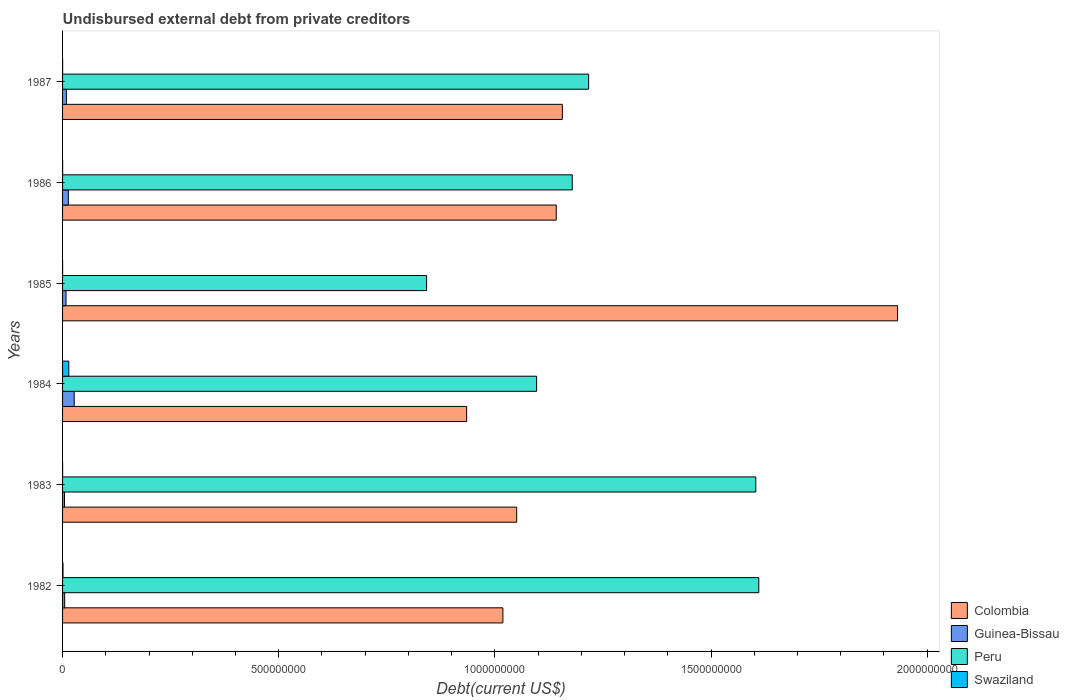How many groups of bars are there?
Provide a succinct answer. 6. Are the number of bars per tick equal to the number of legend labels?
Make the answer very short. Yes. In how many cases, is the number of bars for a given year not equal to the number of legend labels?
Ensure brevity in your answer.  0. What is the total debt in Colombia in 1983?
Ensure brevity in your answer.  1.05e+09. Across all years, what is the maximum total debt in Swaziland?
Give a very brief answer. 1.44e+07. Across all years, what is the minimum total debt in Guinea-Bissau?
Keep it short and to the point. 4.41e+06. In which year was the total debt in Peru minimum?
Provide a succinct answer. 1985. What is the total total debt in Swaziland in the graph?
Provide a short and direct response. 1.59e+07. What is the difference between the total debt in Guinea-Bissau in 1984 and that in 1985?
Your answer should be very brief. 1.90e+07. What is the difference between the total debt in Colombia in 1986 and the total debt in Peru in 1982?
Give a very brief answer. -4.69e+08. What is the average total debt in Colombia per year?
Your answer should be compact. 1.21e+09. In the year 1986, what is the difference between the total debt in Peru and total debt in Swaziland?
Offer a very short reply. 1.18e+09. In how many years, is the total debt in Peru greater than 1800000000 US$?
Your answer should be compact. 0. What is the ratio of the total debt in Swaziland in 1982 to that in 1983?
Provide a succinct answer. 10.61. Is the total debt in Swaziland in 1985 less than that in 1986?
Offer a very short reply. Yes. Is the difference between the total debt in Peru in 1982 and 1986 greater than the difference between the total debt in Swaziland in 1982 and 1986?
Your response must be concise. Yes. What is the difference between the highest and the second highest total debt in Guinea-Bissau?
Provide a short and direct response. 1.36e+07. What is the difference between the highest and the lowest total debt in Guinea-Bissau?
Provide a short and direct response. 2.25e+07. Is it the case that in every year, the sum of the total debt in Swaziland and total debt in Peru is greater than the sum of total debt in Colombia and total debt in Guinea-Bissau?
Your response must be concise. Yes. What does the 2nd bar from the top in 1983 represents?
Keep it short and to the point. Peru. What does the 2nd bar from the bottom in 1985 represents?
Offer a terse response. Guinea-Bissau. Is it the case that in every year, the sum of the total debt in Colombia and total debt in Peru is greater than the total debt in Guinea-Bissau?
Your answer should be very brief. Yes. How many bars are there?
Your answer should be very brief. 24. Are all the bars in the graph horizontal?
Keep it short and to the point. Yes. Are the values on the major ticks of X-axis written in scientific E-notation?
Provide a succinct answer. No. How are the legend labels stacked?
Your answer should be very brief. Vertical. What is the title of the graph?
Your response must be concise. Undisbursed external debt from private creditors. What is the label or title of the X-axis?
Keep it short and to the point. Debt(current US$). What is the label or title of the Y-axis?
Keep it short and to the point. Years. What is the Debt(current US$) in Colombia in 1982?
Provide a short and direct response. 1.02e+09. What is the Debt(current US$) in Guinea-Bissau in 1982?
Provide a succinct answer. 4.88e+06. What is the Debt(current US$) of Peru in 1982?
Give a very brief answer. 1.61e+09. What is the Debt(current US$) of Swaziland in 1982?
Give a very brief answer. 9.87e+05. What is the Debt(current US$) in Colombia in 1983?
Your answer should be very brief. 1.05e+09. What is the Debt(current US$) in Guinea-Bissau in 1983?
Give a very brief answer. 4.41e+06. What is the Debt(current US$) in Peru in 1983?
Provide a succinct answer. 1.60e+09. What is the Debt(current US$) of Swaziland in 1983?
Your response must be concise. 9.30e+04. What is the Debt(current US$) in Colombia in 1984?
Ensure brevity in your answer.  9.35e+08. What is the Debt(current US$) in Guinea-Bissau in 1984?
Offer a very short reply. 2.69e+07. What is the Debt(current US$) of Peru in 1984?
Keep it short and to the point. 1.10e+09. What is the Debt(current US$) of Swaziland in 1984?
Offer a terse response. 1.44e+07. What is the Debt(current US$) in Colombia in 1985?
Offer a terse response. 1.93e+09. What is the Debt(current US$) of Guinea-Bissau in 1985?
Offer a very short reply. 7.95e+06. What is the Debt(current US$) of Peru in 1985?
Your response must be concise. 8.42e+08. What is the Debt(current US$) of Swaziland in 1985?
Offer a terse response. 1.03e+05. What is the Debt(current US$) of Colombia in 1986?
Make the answer very short. 1.14e+09. What is the Debt(current US$) of Guinea-Bissau in 1986?
Your response must be concise. 1.33e+07. What is the Debt(current US$) in Peru in 1986?
Offer a terse response. 1.18e+09. What is the Debt(current US$) in Swaziland in 1986?
Your answer should be very brief. 1.21e+05. What is the Debt(current US$) in Colombia in 1987?
Provide a short and direct response. 1.16e+09. What is the Debt(current US$) in Guinea-Bissau in 1987?
Make the answer very short. 8.89e+06. What is the Debt(current US$) in Peru in 1987?
Your answer should be very brief. 1.22e+09. What is the Debt(current US$) of Swaziland in 1987?
Make the answer very short. 1.46e+05. Across all years, what is the maximum Debt(current US$) in Colombia?
Your answer should be very brief. 1.93e+09. Across all years, what is the maximum Debt(current US$) of Guinea-Bissau?
Keep it short and to the point. 2.69e+07. Across all years, what is the maximum Debt(current US$) in Peru?
Provide a succinct answer. 1.61e+09. Across all years, what is the maximum Debt(current US$) in Swaziland?
Make the answer very short. 1.44e+07. Across all years, what is the minimum Debt(current US$) of Colombia?
Offer a very short reply. 9.35e+08. Across all years, what is the minimum Debt(current US$) of Guinea-Bissau?
Offer a terse response. 4.41e+06. Across all years, what is the minimum Debt(current US$) of Peru?
Offer a terse response. 8.42e+08. Across all years, what is the minimum Debt(current US$) of Swaziland?
Offer a terse response. 9.30e+04. What is the total Debt(current US$) of Colombia in the graph?
Provide a short and direct response. 7.23e+09. What is the total Debt(current US$) in Guinea-Bissau in the graph?
Your answer should be very brief. 6.64e+07. What is the total Debt(current US$) in Peru in the graph?
Provide a short and direct response. 7.55e+09. What is the total Debt(current US$) of Swaziland in the graph?
Your answer should be very brief. 1.59e+07. What is the difference between the Debt(current US$) of Colombia in 1982 and that in 1983?
Offer a terse response. -3.20e+07. What is the difference between the Debt(current US$) of Guinea-Bissau in 1982 and that in 1983?
Provide a short and direct response. 4.74e+05. What is the difference between the Debt(current US$) of Peru in 1982 and that in 1983?
Provide a succinct answer. 6.94e+06. What is the difference between the Debt(current US$) in Swaziland in 1982 and that in 1983?
Offer a terse response. 8.94e+05. What is the difference between the Debt(current US$) of Colombia in 1982 and that in 1984?
Offer a very short reply. 8.38e+07. What is the difference between the Debt(current US$) of Guinea-Bissau in 1982 and that in 1984?
Keep it short and to the point. -2.20e+07. What is the difference between the Debt(current US$) in Peru in 1982 and that in 1984?
Your answer should be compact. 5.14e+08. What is the difference between the Debt(current US$) in Swaziland in 1982 and that in 1984?
Provide a short and direct response. -1.34e+07. What is the difference between the Debt(current US$) in Colombia in 1982 and that in 1985?
Your answer should be compact. -9.13e+08. What is the difference between the Debt(current US$) of Guinea-Bissau in 1982 and that in 1985?
Give a very brief answer. -3.07e+06. What is the difference between the Debt(current US$) in Peru in 1982 and that in 1985?
Make the answer very short. 7.68e+08. What is the difference between the Debt(current US$) of Swaziland in 1982 and that in 1985?
Offer a terse response. 8.84e+05. What is the difference between the Debt(current US$) of Colombia in 1982 and that in 1986?
Offer a terse response. -1.23e+08. What is the difference between the Debt(current US$) in Guinea-Bissau in 1982 and that in 1986?
Offer a terse response. -8.41e+06. What is the difference between the Debt(current US$) of Peru in 1982 and that in 1986?
Give a very brief answer. 4.31e+08. What is the difference between the Debt(current US$) of Swaziland in 1982 and that in 1986?
Your answer should be compact. 8.66e+05. What is the difference between the Debt(current US$) in Colombia in 1982 and that in 1987?
Give a very brief answer. -1.38e+08. What is the difference between the Debt(current US$) of Guinea-Bissau in 1982 and that in 1987?
Offer a terse response. -4.00e+06. What is the difference between the Debt(current US$) in Peru in 1982 and that in 1987?
Your response must be concise. 3.94e+08. What is the difference between the Debt(current US$) in Swaziland in 1982 and that in 1987?
Your answer should be compact. 8.41e+05. What is the difference between the Debt(current US$) in Colombia in 1983 and that in 1984?
Give a very brief answer. 1.16e+08. What is the difference between the Debt(current US$) of Guinea-Bissau in 1983 and that in 1984?
Your response must be concise. -2.25e+07. What is the difference between the Debt(current US$) of Peru in 1983 and that in 1984?
Your answer should be very brief. 5.07e+08. What is the difference between the Debt(current US$) of Swaziland in 1983 and that in 1984?
Offer a terse response. -1.43e+07. What is the difference between the Debt(current US$) of Colombia in 1983 and that in 1985?
Offer a terse response. -8.81e+08. What is the difference between the Debt(current US$) of Guinea-Bissau in 1983 and that in 1985?
Make the answer very short. -3.54e+06. What is the difference between the Debt(current US$) in Peru in 1983 and that in 1985?
Make the answer very short. 7.61e+08. What is the difference between the Debt(current US$) of Colombia in 1983 and that in 1986?
Your response must be concise. -9.15e+07. What is the difference between the Debt(current US$) in Guinea-Bissau in 1983 and that in 1986?
Provide a succinct answer. -8.89e+06. What is the difference between the Debt(current US$) of Peru in 1983 and that in 1986?
Offer a very short reply. 4.25e+08. What is the difference between the Debt(current US$) of Swaziland in 1983 and that in 1986?
Offer a terse response. -2.80e+04. What is the difference between the Debt(current US$) in Colombia in 1983 and that in 1987?
Offer a very short reply. -1.06e+08. What is the difference between the Debt(current US$) in Guinea-Bissau in 1983 and that in 1987?
Give a very brief answer. -4.48e+06. What is the difference between the Debt(current US$) in Peru in 1983 and that in 1987?
Ensure brevity in your answer.  3.87e+08. What is the difference between the Debt(current US$) in Swaziland in 1983 and that in 1987?
Ensure brevity in your answer.  -5.30e+04. What is the difference between the Debt(current US$) of Colombia in 1984 and that in 1985?
Your answer should be compact. -9.97e+08. What is the difference between the Debt(current US$) of Guinea-Bissau in 1984 and that in 1985?
Your answer should be very brief. 1.90e+07. What is the difference between the Debt(current US$) of Peru in 1984 and that in 1985?
Your answer should be very brief. 2.54e+08. What is the difference between the Debt(current US$) in Swaziland in 1984 and that in 1985?
Provide a succinct answer. 1.43e+07. What is the difference between the Debt(current US$) of Colombia in 1984 and that in 1986?
Ensure brevity in your answer.  -2.07e+08. What is the difference between the Debt(current US$) of Guinea-Bissau in 1984 and that in 1986?
Offer a terse response. 1.36e+07. What is the difference between the Debt(current US$) of Peru in 1984 and that in 1986?
Make the answer very short. -8.25e+07. What is the difference between the Debt(current US$) of Swaziland in 1984 and that in 1986?
Offer a terse response. 1.43e+07. What is the difference between the Debt(current US$) in Colombia in 1984 and that in 1987?
Offer a very short reply. -2.21e+08. What is the difference between the Debt(current US$) of Guinea-Bissau in 1984 and that in 1987?
Ensure brevity in your answer.  1.80e+07. What is the difference between the Debt(current US$) in Peru in 1984 and that in 1987?
Your answer should be very brief. -1.20e+08. What is the difference between the Debt(current US$) in Swaziland in 1984 and that in 1987?
Ensure brevity in your answer.  1.43e+07. What is the difference between the Debt(current US$) of Colombia in 1985 and that in 1986?
Offer a very short reply. 7.90e+08. What is the difference between the Debt(current US$) of Guinea-Bissau in 1985 and that in 1986?
Your answer should be compact. -5.34e+06. What is the difference between the Debt(current US$) in Peru in 1985 and that in 1986?
Offer a terse response. -3.37e+08. What is the difference between the Debt(current US$) in Swaziland in 1985 and that in 1986?
Ensure brevity in your answer.  -1.80e+04. What is the difference between the Debt(current US$) in Colombia in 1985 and that in 1987?
Ensure brevity in your answer.  7.75e+08. What is the difference between the Debt(current US$) in Guinea-Bissau in 1985 and that in 1987?
Give a very brief answer. -9.33e+05. What is the difference between the Debt(current US$) in Peru in 1985 and that in 1987?
Ensure brevity in your answer.  -3.75e+08. What is the difference between the Debt(current US$) in Swaziland in 1985 and that in 1987?
Give a very brief answer. -4.30e+04. What is the difference between the Debt(current US$) in Colombia in 1986 and that in 1987?
Your response must be concise. -1.41e+07. What is the difference between the Debt(current US$) in Guinea-Bissau in 1986 and that in 1987?
Provide a succinct answer. 4.41e+06. What is the difference between the Debt(current US$) of Peru in 1986 and that in 1987?
Make the answer very short. -3.78e+07. What is the difference between the Debt(current US$) in Swaziland in 1986 and that in 1987?
Provide a short and direct response. -2.50e+04. What is the difference between the Debt(current US$) in Colombia in 1982 and the Debt(current US$) in Guinea-Bissau in 1983?
Your answer should be compact. 1.01e+09. What is the difference between the Debt(current US$) in Colombia in 1982 and the Debt(current US$) in Peru in 1983?
Offer a very short reply. -5.85e+08. What is the difference between the Debt(current US$) in Colombia in 1982 and the Debt(current US$) in Swaziland in 1983?
Give a very brief answer. 1.02e+09. What is the difference between the Debt(current US$) in Guinea-Bissau in 1982 and the Debt(current US$) in Peru in 1983?
Ensure brevity in your answer.  -1.60e+09. What is the difference between the Debt(current US$) in Guinea-Bissau in 1982 and the Debt(current US$) in Swaziland in 1983?
Provide a short and direct response. 4.79e+06. What is the difference between the Debt(current US$) in Peru in 1982 and the Debt(current US$) in Swaziland in 1983?
Provide a succinct answer. 1.61e+09. What is the difference between the Debt(current US$) in Colombia in 1982 and the Debt(current US$) in Guinea-Bissau in 1984?
Your response must be concise. 9.92e+08. What is the difference between the Debt(current US$) in Colombia in 1982 and the Debt(current US$) in Peru in 1984?
Your response must be concise. -7.80e+07. What is the difference between the Debt(current US$) in Colombia in 1982 and the Debt(current US$) in Swaziland in 1984?
Ensure brevity in your answer.  1.00e+09. What is the difference between the Debt(current US$) of Guinea-Bissau in 1982 and the Debt(current US$) of Peru in 1984?
Keep it short and to the point. -1.09e+09. What is the difference between the Debt(current US$) in Guinea-Bissau in 1982 and the Debt(current US$) in Swaziland in 1984?
Give a very brief answer. -9.52e+06. What is the difference between the Debt(current US$) of Peru in 1982 and the Debt(current US$) of Swaziland in 1984?
Your answer should be very brief. 1.60e+09. What is the difference between the Debt(current US$) of Colombia in 1982 and the Debt(current US$) of Guinea-Bissau in 1985?
Keep it short and to the point. 1.01e+09. What is the difference between the Debt(current US$) of Colombia in 1982 and the Debt(current US$) of Peru in 1985?
Your response must be concise. 1.76e+08. What is the difference between the Debt(current US$) in Colombia in 1982 and the Debt(current US$) in Swaziland in 1985?
Offer a terse response. 1.02e+09. What is the difference between the Debt(current US$) of Guinea-Bissau in 1982 and the Debt(current US$) of Peru in 1985?
Provide a succinct answer. -8.37e+08. What is the difference between the Debt(current US$) of Guinea-Bissau in 1982 and the Debt(current US$) of Swaziland in 1985?
Make the answer very short. 4.78e+06. What is the difference between the Debt(current US$) in Peru in 1982 and the Debt(current US$) in Swaziland in 1985?
Give a very brief answer. 1.61e+09. What is the difference between the Debt(current US$) in Colombia in 1982 and the Debt(current US$) in Guinea-Bissau in 1986?
Keep it short and to the point. 1.01e+09. What is the difference between the Debt(current US$) of Colombia in 1982 and the Debt(current US$) of Peru in 1986?
Offer a terse response. -1.60e+08. What is the difference between the Debt(current US$) in Colombia in 1982 and the Debt(current US$) in Swaziland in 1986?
Provide a succinct answer. 1.02e+09. What is the difference between the Debt(current US$) of Guinea-Bissau in 1982 and the Debt(current US$) of Peru in 1986?
Your answer should be very brief. -1.17e+09. What is the difference between the Debt(current US$) of Guinea-Bissau in 1982 and the Debt(current US$) of Swaziland in 1986?
Your answer should be very brief. 4.76e+06. What is the difference between the Debt(current US$) in Peru in 1982 and the Debt(current US$) in Swaziland in 1986?
Your answer should be very brief. 1.61e+09. What is the difference between the Debt(current US$) of Colombia in 1982 and the Debt(current US$) of Guinea-Bissau in 1987?
Your answer should be very brief. 1.01e+09. What is the difference between the Debt(current US$) of Colombia in 1982 and the Debt(current US$) of Peru in 1987?
Ensure brevity in your answer.  -1.98e+08. What is the difference between the Debt(current US$) of Colombia in 1982 and the Debt(current US$) of Swaziland in 1987?
Ensure brevity in your answer.  1.02e+09. What is the difference between the Debt(current US$) in Guinea-Bissau in 1982 and the Debt(current US$) in Peru in 1987?
Ensure brevity in your answer.  -1.21e+09. What is the difference between the Debt(current US$) of Guinea-Bissau in 1982 and the Debt(current US$) of Swaziland in 1987?
Your answer should be compact. 4.74e+06. What is the difference between the Debt(current US$) in Peru in 1982 and the Debt(current US$) in Swaziland in 1987?
Give a very brief answer. 1.61e+09. What is the difference between the Debt(current US$) of Colombia in 1983 and the Debt(current US$) of Guinea-Bissau in 1984?
Your answer should be very brief. 1.02e+09. What is the difference between the Debt(current US$) in Colombia in 1983 and the Debt(current US$) in Peru in 1984?
Offer a terse response. -4.60e+07. What is the difference between the Debt(current US$) in Colombia in 1983 and the Debt(current US$) in Swaziland in 1984?
Ensure brevity in your answer.  1.04e+09. What is the difference between the Debt(current US$) of Guinea-Bissau in 1983 and the Debt(current US$) of Peru in 1984?
Provide a short and direct response. -1.09e+09. What is the difference between the Debt(current US$) of Guinea-Bissau in 1983 and the Debt(current US$) of Swaziland in 1984?
Keep it short and to the point. -9.99e+06. What is the difference between the Debt(current US$) in Peru in 1983 and the Debt(current US$) in Swaziland in 1984?
Offer a terse response. 1.59e+09. What is the difference between the Debt(current US$) of Colombia in 1983 and the Debt(current US$) of Guinea-Bissau in 1985?
Your answer should be compact. 1.04e+09. What is the difference between the Debt(current US$) in Colombia in 1983 and the Debt(current US$) in Peru in 1985?
Your answer should be very brief. 2.08e+08. What is the difference between the Debt(current US$) in Colombia in 1983 and the Debt(current US$) in Swaziland in 1985?
Provide a succinct answer. 1.05e+09. What is the difference between the Debt(current US$) in Guinea-Bissau in 1983 and the Debt(current US$) in Peru in 1985?
Give a very brief answer. -8.38e+08. What is the difference between the Debt(current US$) in Guinea-Bissau in 1983 and the Debt(current US$) in Swaziland in 1985?
Provide a short and direct response. 4.31e+06. What is the difference between the Debt(current US$) in Peru in 1983 and the Debt(current US$) in Swaziland in 1985?
Provide a succinct answer. 1.60e+09. What is the difference between the Debt(current US$) of Colombia in 1983 and the Debt(current US$) of Guinea-Bissau in 1986?
Provide a succinct answer. 1.04e+09. What is the difference between the Debt(current US$) in Colombia in 1983 and the Debt(current US$) in Peru in 1986?
Offer a very short reply. -1.29e+08. What is the difference between the Debt(current US$) of Colombia in 1983 and the Debt(current US$) of Swaziland in 1986?
Your response must be concise. 1.05e+09. What is the difference between the Debt(current US$) of Guinea-Bissau in 1983 and the Debt(current US$) of Peru in 1986?
Offer a terse response. -1.17e+09. What is the difference between the Debt(current US$) in Guinea-Bissau in 1983 and the Debt(current US$) in Swaziland in 1986?
Your answer should be compact. 4.29e+06. What is the difference between the Debt(current US$) of Peru in 1983 and the Debt(current US$) of Swaziland in 1986?
Your answer should be very brief. 1.60e+09. What is the difference between the Debt(current US$) of Colombia in 1983 and the Debt(current US$) of Guinea-Bissau in 1987?
Provide a short and direct response. 1.04e+09. What is the difference between the Debt(current US$) of Colombia in 1983 and the Debt(current US$) of Peru in 1987?
Give a very brief answer. -1.66e+08. What is the difference between the Debt(current US$) of Colombia in 1983 and the Debt(current US$) of Swaziland in 1987?
Make the answer very short. 1.05e+09. What is the difference between the Debt(current US$) of Guinea-Bissau in 1983 and the Debt(current US$) of Peru in 1987?
Make the answer very short. -1.21e+09. What is the difference between the Debt(current US$) in Guinea-Bissau in 1983 and the Debt(current US$) in Swaziland in 1987?
Provide a short and direct response. 4.26e+06. What is the difference between the Debt(current US$) in Peru in 1983 and the Debt(current US$) in Swaziland in 1987?
Provide a short and direct response. 1.60e+09. What is the difference between the Debt(current US$) of Colombia in 1984 and the Debt(current US$) of Guinea-Bissau in 1985?
Your answer should be very brief. 9.27e+08. What is the difference between the Debt(current US$) in Colombia in 1984 and the Debt(current US$) in Peru in 1985?
Give a very brief answer. 9.26e+07. What is the difference between the Debt(current US$) of Colombia in 1984 and the Debt(current US$) of Swaziland in 1985?
Your response must be concise. 9.35e+08. What is the difference between the Debt(current US$) of Guinea-Bissau in 1984 and the Debt(current US$) of Peru in 1985?
Provide a short and direct response. -8.15e+08. What is the difference between the Debt(current US$) in Guinea-Bissau in 1984 and the Debt(current US$) in Swaziland in 1985?
Make the answer very short. 2.68e+07. What is the difference between the Debt(current US$) in Peru in 1984 and the Debt(current US$) in Swaziland in 1985?
Ensure brevity in your answer.  1.10e+09. What is the difference between the Debt(current US$) of Colombia in 1984 and the Debt(current US$) of Guinea-Bissau in 1986?
Keep it short and to the point. 9.21e+08. What is the difference between the Debt(current US$) in Colombia in 1984 and the Debt(current US$) in Peru in 1986?
Keep it short and to the point. -2.44e+08. What is the difference between the Debt(current US$) in Colombia in 1984 and the Debt(current US$) in Swaziland in 1986?
Your answer should be very brief. 9.35e+08. What is the difference between the Debt(current US$) of Guinea-Bissau in 1984 and the Debt(current US$) of Peru in 1986?
Make the answer very short. -1.15e+09. What is the difference between the Debt(current US$) of Guinea-Bissau in 1984 and the Debt(current US$) of Swaziland in 1986?
Give a very brief answer. 2.68e+07. What is the difference between the Debt(current US$) of Peru in 1984 and the Debt(current US$) of Swaziland in 1986?
Offer a very short reply. 1.10e+09. What is the difference between the Debt(current US$) in Colombia in 1984 and the Debt(current US$) in Guinea-Bissau in 1987?
Ensure brevity in your answer.  9.26e+08. What is the difference between the Debt(current US$) of Colombia in 1984 and the Debt(current US$) of Peru in 1987?
Provide a short and direct response. -2.82e+08. What is the difference between the Debt(current US$) in Colombia in 1984 and the Debt(current US$) in Swaziland in 1987?
Offer a very short reply. 9.35e+08. What is the difference between the Debt(current US$) of Guinea-Bissau in 1984 and the Debt(current US$) of Peru in 1987?
Make the answer very short. -1.19e+09. What is the difference between the Debt(current US$) of Guinea-Bissau in 1984 and the Debt(current US$) of Swaziland in 1987?
Give a very brief answer. 2.68e+07. What is the difference between the Debt(current US$) in Peru in 1984 and the Debt(current US$) in Swaziland in 1987?
Give a very brief answer. 1.10e+09. What is the difference between the Debt(current US$) of Colombia in 1985 and the Debt(current US$) of Guinea-Bissau in 1986?
Provide a short and direct response. 1.92e+09. What is the difference between the Debt(current US$) in Colombia in 1985 and the Debt(current US$) in Peru in 1986?
Offer a terse response. 7.52e+08. What is the difference between the Debt(current US$) in Colombia in 1985 and the Debt(current US$) in Swaziland in 1986?
Make the answer very short. 1.93e+09. What is the difference between the Debt(current US$) of Guinea-Bissau in 1985 and the Debt(current US$) of Peru in 1986?
Offer a terse response. -1.17e+09. What is the difference between the Debt(current US$) of Guinea-Bissau in 1985 and the Debt(current US$) of Swaziland in 1986?
Offer a very short reply. 7.83e+06. What is the difference between the Debt(current US$) in Peru in 1985 and the Debt(current US$) in Swaziland in 1986?
Provide a short and direct response. 8.42e+08. What is the difference between the Debt(current US$) in Colombia in 1985 and the Debt(current US$) in Guinea-Bissau in 1987?
Provide a short and direct response. 1.92e+09. What is the difference between the Debt(current US$) of Colombia in 1985 and the Debt(current US$) of Peru in 1987?
Your answer should be very brief. 7.15e+08. What is the difference between the Debt(current US$) in Colombia in 1985 and the Debt(current US$) in Swaziland in 1987?
Your answer should be compact. 1.93e+09. What is the difference between the Debt(current US$) of Guinea-Bissau in 1985 and the Debt(current US$) of Peru in 1987?
Your response must be concise. -1.21e+09. What is the difference between the Debt(current US$) in Guinea-Bissau in 1985 and the Debt(current US$) in Swaziland in 1987?
Provide a short and direct response. 7.81e+06. What is the difference between the Debt(current US$) in Peru in 1985 and the Debt(current US$) in Swaziland in 1987?
Ensure brevity in your answer.  8.42e+08. What is the difference between the Debt(current US$) in Colombia in 1986 and the Debt(current US$) in Guinea-Bissau in 1987?
Provide a succinct answer. 1.13e+09. What is the difference between the Debt(current US$) of Colombia in 1986 and the Debt(current US$) of Peru in 1987?
Offer a very short reply. -7.49e+07. What is the difference between the Debt(current US$) in Colombia in 1986 and the Debt(current US$) in Swaziland in 1987?
Ensure brevity in your answer.  1.14e+09. What is the difference between the Debt(current US$) in Guinea-Bissau in 1986 and the Debt(current US$) in Peru in 1987?
Ensure brevity in your answer.  -1.20e+09. What is the difference between the Debt(current US$) in Guinea-Bissau in 1986 and the Debt(current US$) in Swaziland in 1987?
Give a very brief answer. 1.32e+07. What is the difference between the Debt(current US$) in Peru in 1986 and the Debt(current US$) in Swaziland in 1987?
Offer a very short reply. 1.18e+09. What is the average Debt(current US$) in Colombia per year?
Make the answer very short. 1.21e+09. What is the average Debt(current US$) in Guinea-Bissau per year?
Offer a terse response. 1.11e+07. What is the average Debt(current US$) of Peru per year?
Give a very brief answer. 1.26e+09. What is the average Debt(current US$) of Swaziland per year?
Your answer should be compact. 2.64e+06. In the year 1982, what is the difference between the Debt(current US$) of Colombia and Debt(current US$) of Guinea-Bissau?
Provide a succinct answer. 1.01e+09. In the year 1982, what is the difference between the Debt(current US$) in Colombia and Debt(current US$) in Peru?
Ensure brevity in your answer.  -5.92e+08. In the year 1982, what is the difference between the Debt(current US$) of Colombia and Debt(current US$) of Swaziland?
Ensure brevity in your answer.  1.02e+09. In the year 1982, what is the difference between the Debt(current US$) in Guinea-Bissau and Debt(current US$) in Peru?
Offer a terse response. -1.61e+09. In the year 1982, what is the difference between the Debt(current US$) in Guinea-Bissau and Debt(current US$) in Swaziland?
Keep it short and to the point. 3.90e+06. In the year 1982, what is the difference between the Debt(current US$) in Peru and Debt(current US$) in Swaziland?
Offer a very short reply. 1.61e+09. In the year 1983, what is the difference between the Debt(current US$) of Colombia and Debt(current US$) of Guinea-Bissau?
Ensure brevity in your answer.  1.05e+09. In the year 1983, what is the difference between the Debt(current US$) in Colombia and Debt(current US$) in Peru?
Give a very brief answer. -5.53e+08. In the year 1983, what is the difference between the Debt(current US$) in Colombia and Debt(current US$) in Swaziland?
Your response must be concise. 1.05e+09. In the year 1983, what is the difference between the Debt(current US$) in Guinea-Bissau and Debt(current US$) in Peru?
Offer a very short reply. -1.60e+09. In the year 1983, what is the difference between the Debt(current US$) in Guinea-Bissau and Debt(current US$) in Swaziland?
Ensure brevity in your answer.  4.32e+06. In the year 1983, what is the difference between the Debt(current US$) in Peru and Debt(current US$) in Swaziland?
Make the answer very short. 1.60e+09. In the year 1984, what is the difference between the Debt(current US$) in Colombia and Debt(current US$) in Guinea-Bissau?
Your response must be concise. 9.08e+08. In the year 1984, what is the difference between the Debt(current US$) in Colombia and Debt(current US$) in Peru?
Give a very brief answer. -1.62e+08. In the year 1984, what is the difference between the Debt(current US$) in Colombia and Debt(current US$) in Swaziland?
Your response must be concise. 9.20e+08. In the year 1984, what is the difference between the Debt(current US$) of Guinea-Bissau and Debt(current US$) of Peru?
Your response must be concise. -1.07e+09. In the year 1984, what is the difference between the Debt(current US$) of Guinea-Bissau and Debt(current US$) of Swaziland?
Make the answer very short. 1.25e+07. In the year 1984, what is the difference between the Debt(current US$) of Peru and Debt(current US$) of Swaziland?
Ensure brevity in your answer.  1.08e+09. In the year 1985, what is the difference between the Debt(current US$) of Colombia and Debt(current US$) of Guinea-Bissau?
Your response must be concise. 1.92e+09. In the year 1985, what is the difference between the Debt(current US$) in Colombia and Debt(current US$) in Peru?
Make the answer very short. 1.09e+09. In the year 1985, what is the difference between the Debt(current US$) of Colombia and Debt(current US$) of Swaziland?
Your answer should be very brief. 1.93e+09. In the year 1985, what is the difference between the Debt(current US$) in Guinea-Bissau and Debt(current US$) in Peru?
Give a very brief answer. -8.34e+08. In the year 1985, what is the difference between the Debt(current US$) in Guinea-Bissau and Debt(current US$) in Swaziland?
Offer a very short reply. 7.85e+06. In the year 1985, what is the difference between the Debt(current US$) in Peru and Debt(current US$) in Swaziland?
Offer a terse response. 8.42e+08. In the year 1986, what is the difference between the Debt(current US$) in Colombia and Debt(current US$) in Guinea-Bissau?
Keep it short and to the point. 1.13e+09. In the year 1986, what is the difference between the Debt(current US$) of Colombia and Debt(current US$) of Peru?
Offer a very short reply. -3.71e+07. In the year 1986, what is the difference between the Debt(current US$) of Colombia and Debt(current US$) of Swaziland?
Keep it short and to the point. 1.14e+09. In the year 1986, what is the difference between the Debt(current US$) in Guinea-Bissau and Debt(current US$) in Peru?
Ensure brevity in your answer.  -1.17e+09. In the year 1986, what is the difference between the Debt(current US$) of Guinea-Bissau and Debt(current US$) of Swaziland?
Provide a short and direct response. 1.32e+07. In the year 1986, what is the difference between the Debt(current US$) of Peru and Debt(current US$) of Swaziland?
Offer a terse response. 1.18e+09. In the year 1987, what is the difference between the Debt(current US$) in Colombia and Debt(current US$) in Guinea-Bissau?
Your answer should be compact. 1.15e+09. In the year 1987, what is the difference between the Debt(current US$) in Colombia and Debt(current US$) in Peru?
Make the answer very short. -6.08e+07. In the year 1987, what is the difference between the Debt(current US$) of Colombia and Debt(current US$) of Swaziland?
Make the answer very short. 1.16e+09. In the year 1987, what is the difference between the Debt(current US$) of Guinea-Bissau and Debt(current US$) of Peru?
Your response must be concise. -1.21e+09. In the year 1987, what is the difference between the Debt(current US$) of Guinea-Bissau and Debt(current US$) of Swaziland?
Provide a short and direct response. 8.74e+06. In the year 1987, what is the difference between the Debt(current US$) in Peru and Debt(current US$) in Swaziland?
Ensure brevity in your answer.  1.22e+09. What is the ratio of the Debt(current US$) of Colombia in 1982 to that in 1983?
Your answer should be compact. 0.97. What is the ratio of the Debt(current US$) in Guinea-Bissau in 1982 to that in 1983?
Your answer should be compact. 1.11. What is the ratio of the Debt(current US$) in Swaziland in 1982 to that in 1983?
Your response must be concise. 10.61. What is the ratio of the Debt(current US$) of Colombia in 1982 to that in 1984?
Provide a short and direct response. 1.09. What is the ratio of the Debt(current US$) in Guinea-Bissau in 1982 to that in 1984?
Offer a very short reply. 0.18. What is the ratio of the Debt(current US$) of Peru in 1982 to that in 1984?
Offer a very short reply. 1.47. What is the ratio of the Debt(current US$) in Swaziland in 1982 to that in 1984?
Give a very brief answer. 0.07. What is the ratio of the Debt(current US$) of Colombia in 1982 to that in 1985?
Offer a very short reply. 0.53. What is the ratio of the Debt(current US$) in Guinea-Bissau in 1982 to that in 1985?
Provide a succinct answer. 0.61. What is the ratio of the Debt(current US$) of Peru in 1982 to that in 1985?
Your answer should be compact. 1.91. What is the ratio of the Debt(current US$) in Swaziland in 1982 to that in 1985?
Keep it short and to the point. 9.58. What is the ratio of the Debt(current US$) of Colombia in 1982 to that in 1986?
Offer a very short reply. 0.89. What is the ratio of the Debt(current US$) of Guinea-Bissau in 1982 to that in 1986?
Your answer should be compact. 0.37. What is the ratio of the Debt(current US$) in Peru in 1982 to that in 1986?
Your answer should be compact. 1.37. What is the ratio of the Debt(current US$) in Swaziland in 1982 to that in 1986?
Ensure brevity in your answer.  8.16. What is the ratio of the Debt(current US$) of Colombia in 1982 to that in 1987?
Make the answer very short. 0.88. What is the ratio of the Debt(current US$) of Guinea-Bissau in 1982 to that in 1987?
Make the answer very short. 0.55. What is the ratio of the Debt(current US$) of Peru in 1982 to that in 1987?
Provide a short and direct response. 1.32. What is the ratio of the Debt(current US$) in Swaziland in 1982 to that in 1987?
Provide a short and direct response. 6.76. What is the ratio of the Debt(current US$) in Colombia in 1983 to that in 1984?
Your answer should be compact. 1.12. What is the ratio of the Debt(current US$) in Guinea-Bissau in 1983 to that in 1984?
Offer a very short reply. 0.16. What is the ratio of the Debt(current US$) in Peru in 1983 to that in 1984?
Offer a terse response. 1.46. What is the ratio of the Debt(current US$) of Swaziland in 1983 to that in 1984?
Make the answer very short. 0.01. What is the ratio of the Debt(current US$) in Colombia in 1983 to that in 1985?
Keep it short and to the point. 0.54. What is the ratio of the Debt(current US$) in Guinea-Bissau in 1983 to that in 1985?
Your response must be concise. 0.55. What is the ratio of the Debt(current US$) of Peru in 1983 to that in 1985?
Offer a very short reply. 1.9. What is the ratio of the Debt(current US$) of Swaziland in 1983 to that in 1985?
Keep it short and to the point. 0.9. What is the ratio of the Debt(current US$) of Colombia in 1983 to that in 1986?
Give a very brief answer. 0.92. What is the ratio of the Debt(current US$) of Guinea-Bissau in 1983 to that in 1986?
Give a very brief answer. 0.33. What is the ratio of the Debt(current US$) in Peru in 1983 to that in 1986?
Give a very brief answer. 1.36. What is the ratio of the Debt(current US$) in Swaziland in 1983 to that in 1986?
Your answer should be very brief. 0.77. What is the ratio of the Debt(current US$) of Colombia in 1983 to that in 1987?
Ensure brevity in your answer.  0.91. What is the ratio of the Debt(current US$) of Guinea-Bissau in 1983 to that in 1987?
Ensure brevity in your answer.  0.5. What is the ratio of the Debt(current US$) in Peru in 1983 to that in 1987?
Provide a short and direct response. 1.32. What is the ratio of the Debt(current US$) of Swaziland in 1983 to that in 1987?
Your answer should be very brief. 0.64. What is the ratio of the Debt(current US$) of Colombia in 1984 to that in 1985?
Ensure brevity in your answer.  0.48. What is the ratio of the Debt(current US$) in Guinea-Bissau in 1984 to that in 1985?
Provide a short and direct response. 3.39. What is the ratio of the Debt(current US$) of Peru in 1984 to that in 1985?
Keep it short and to the point. 1.3. What is the ratio of the Debt(current US$) of Swaziland in 1984 to that in 1985?
Keep it short and to the point. 139.84. What is the ratio of the Debt(current US$) of Colombia in 1984 to that in 1986?
Offer a terse response. 0.82. What is the ratio of the Debt(current US$) of Guinea-Bissau in 1984 to that in 1986?
Offer a terse response. 2.03. What is the ratio of the Debt(current US$) of Swaziland in 1984 to that in 1986?
Your response must be concise. 119.04. What is the ratio of the Debt(current US$) in Colombia in 1984 to that in 1987?
Ensure brevity in your answer.  0.81. What is the ratio of the Debt(current US$) of Guinea-Bissau in 1984 to that in 1987?
Make the answer very short. 3.03. What is the ratio of the Debt(current US$) of Peru in 1984 to that in 1987?
Keep it short and to the point. 0.9. What is the ratio of the Debt(current US$) of Swaziland in 1984 to that in 1987?
Your answer should be compact. 98.66. What is the ratio of the Debt(current US$) in Colombia in 1985 to that in 1986?
Provide a short and direct response. 1.69. What is the ratio of the Debt(current US$) of Guinea-Bissau in 1985 to that in 1986?
Your response must be concise. 0.6. What is the ratio of the Debt(current US$) of Peru in 1985 to that in 1986?
Provide a succinct answer. 0.71. What is the ratio of the Debt(current US$) of Swaziland in 1985 to that in 1986?
Provide a succinct answer. 0.85. What is the ratio of the Debt(current US$) in Colombia in 1985 to that in 1987?
Ensure brevity in your answer.  1.67. What is the ratio of the Debt(current US$) of Guinea-Bissau in 1985 to that in 1987?
Keep it short and to the point. 0.9. What is the ratio of the Debt(current US$) in Peru in 1985 to that in 1987?
Provide a short and direct response. 0.69. What is the ratio of the Debt(current US$) of Swaziland in 1985 to that in 1987?
Your answer should be very brief. 0.71. What is the ratio of the Debt(current US$) of Guinea-Bissau in 1986 to that in 1987?
Offer a terse response. 1.5. What is the ratio of the Debt(current US$) in Peru in 1986 to that in 1987?
Ensure brevity in your answer.  0.97. What is the ratio of the Debt(current US$) of Swaziland in 1986 to that in 1987?
Keep it short and to the point. 0.83. What is the difference between the highest and the second highest Debt(current US$) of Colombia?
Give a very brief answer. 7.75e+08. What is the difference between the highest and the second highest Debt(current US$) of Guinea-Bissau?
Provide a succinct answer. 1.36e+07. What is the difference between the highest and the second highest Debt(current US$) in Peru?
Provide a short and direct response. 6.94e+06. What is the difference between the highest and the second highest Debt(current US$) of Swaziland?
Make the answer very short. 1.34e+07. What is the difference between the highest and the lowest Debt(current US$) of Colombia?
Your answer should be compact. 9.97e+08. What is the difference between the highest and the lowest Debt(current US$) in Guinea-Bissau?
Your answer should be compact. 2.25e+07. What is the difference between the highest and the lowest Debt(current US$) of Peru?
Provide a short and direct response. 7.68e+08. What is the difference between the highest and the lowest Debt(current US$) of Swaziland?
Offer a terse response. 1.43e+07. 